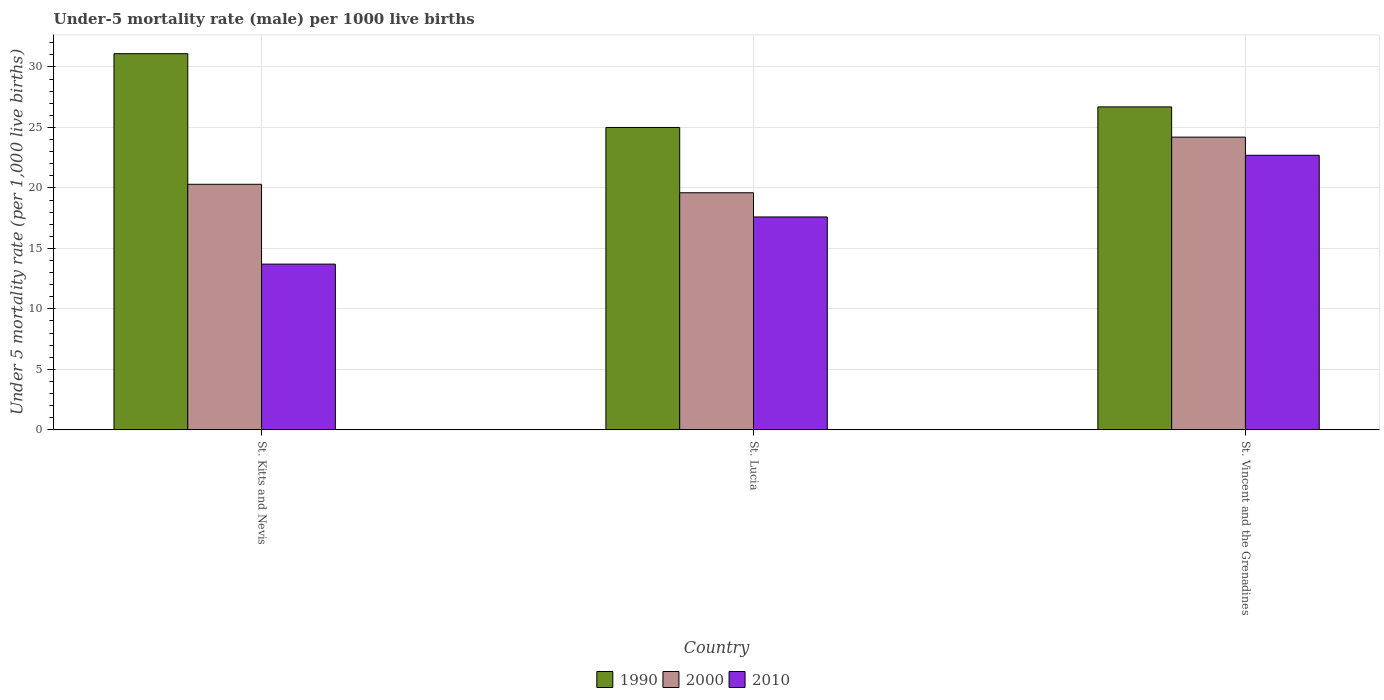Are the number of bars per tick equal to the number of legend labels?
Make the answer very short. Yes. What is the label of the 1st group of bars from the left?
Offer a terse response. St. Kitts and Nevis. Across all countries, what is the maximum under-five mortality rate in 2000?
Keep it short and to the point. 24.2. In which country was the under-five mortality rate in 2010 maximum?
Keep it short and to the point. St. Vincent and the Grenadines. In which country was the under-five mortality rate in 2000 minimum?
Ensure brevity in your answer.  St. Lucia. What is the total under-five mortality rate in 2010 in the graph?
Keep it short and to the point. 54. What is the difference between the under-five mortality rate in 2000 in St. Kitts and Nevis and that in St. Vincent and the Grenadines?
Keep it short and to the point. -3.9. What is the difference between the under-five mortality rate in 1990 in St. Vincent and the Grenadines and the under-five mortality rate in 2010 in St. Kitts and Nevis?
Offer a very short reply. 13. What is the average under-five mortality rate in 2000 per country?
Your answer should be compact. 21.37. What is the difference between the under-five mortality rate of/in 2000 and under-five mortality rate of/in 2010 in St. Kitts and Nevis?
Give a very brief answer. 6.6. What is the ratio of the under-five mortality rate in 2000 in St. Kitts and Nevis to that in St. Vincent and the Grenadines?
Ensure brevity in your answer.  0.84. What is the difference between the highest and the second highest under-five mortality rate in 1990?
Offer a terse response. -1.7. In how many countries, is the under-five mortality rate in 2010 greater than the average under-five mortality rate in 2010 taken over all countries?
Your answer should be compact. 1. What does the 2nd bar from the left in St. Kitts and Nevis represents?
Ensure brevity in your answer.  2000. What does the 3rd bar from the right in St. Kitts and Nevis represents?
Make the answer very short. 1990. Are all the bars in the graph horizontal?
Keep it short and to the point. No. How many countries are there in the graph?
Provide a succinct answer. 3. What is the difference between two consecutive major ticks on the Y-axis?
Give a very brief answer. 5. Are the values on the major ticks of Y-axis written in scientific E-notation?
Provide a short and direct response. No. Does the graph contain grids?
Your response must be concise. Yes. How many legend labels are there?
Give a very brief answer. 3. What is the title of the graph?
Your response must be concise. Under-5 mortality rate (male) per 1000 live births. Does "2007" appear as one of the legend labels in the graph?
Offer a very short reply. No. What is the label or title of the X-axis?
Keep it short and to the point. Country. What is the label or title of the Y-axis?
Provide a short and direct response. Under 5 mortality rate (per 1,0 live births). What is the Under 5 mortality rate (per 1,000 live births) of 1990 in St. Kitts and Nevis?
Keep it short and to the point. 31.1. What is the Under 5 mortality rate (per 1,000 live births) of 2000 in St. Kitts and Nevis?
Give a very brief answer. 20.3. What is the Under 5 mortality rate (per 1,000 live births) of 2010 in St. Kitts and Nevis?
Your answer should be very brief. 13.7. What is the Under 5 mortality rate (per 1,000 live births) of 2000 in St. Lucia?
Offer a very short reply. 19.6. What is the Under 5 mortality rate (per 1,000 live births) of 1990 in St. Vincent and the Grenadines?
Make the answer very short. 26.7. What is the Under 5 mortality rate (per 1,000 live births) of 2000 in St. Vincent and the Grenadines?
Your answer should be compact. 24.2. What is the Under 5 mortality rate (per 1,000 live births) in 2010 in St. Vincent and the Grenadines?
Your response must be concise. 22.7. Across all countries, what is the maximum Under 5 mortality rate (per 1,000 live births) of 1990?
Your answer should be very brief. 31.1. Across all countries, what is the maximum Under 5 mortality rate (per 1,000 live births) in 2000?
Provide a succinct answer. 24.2. Across all countries, what is the maximum Under 5 mortality rate (per 1,000 live births) of 2010?
Your answer should be compact. 22.7. Across all countries, what is the minimum Under 5 mortality rate (per 1,000 live births) in 2000?
Give a very brief answer. 19.6. What is the total Under 5 mortality rate (per 1,000 live births) of 1990 in the graph?
Offer a terse response. 82.8. What is the total Under 5 mortality rate (per 1,000 live births) of 2000 in the graph?
Offer a very short reply. 64.1. What is the total Under 5 mortality rate (per 1,000 live births) of 2010 in the graph?
Offer a terse response. 54. What is the difference between the Under 5 mortality rate (per 1,000 live births) of 1990 in St. Kitts and Nevis and that in St. Lucia?
Provide a succinct answer. 6.1. What is the difference between the Under 5 mortality rate (per 1,000 live births) in 1990 in St. Kitts and Nevis and that in St. Vincent and the Grenadines?
Provide a succinct answer. 4.4. What is the difference between the Under 5 mortality rate (per 1,000 live births) of 2000 in St. Kitts and Nevis and that in St. Vincent and the Grenadines?
Provide a succinct answer. -3.9. What is the difference between the Under 5 mortality rate (per 1,000 live births) of 2000 in St. Lucia and that in St. Vincent and the Grenadines?
Keep it short and to the point. -4.6. What is the difference between the Under 5 mortality rate (per 1,000 live births) of 1990 in St. Kitts and Nevis and the Under 5 mortality rate (per 1,000 live births) of 2010 in St. Lucia?
Ensure brevity in your answer.  13.5. What is the difference between the Under 5 mortality rate (per 1,000 live births) in 1990 in St. Kitts and Nevis and the Under 5 mortality rate (per 1,000 live births) in 2010 in St. Vincent and the Grenadines?
Offer a terse response. 8.4. What is the average Under 5 mortality rate (per 1,000 live births) in 1990 per country?
Make the answer very short. 27.6. What is the average Under 5 mortality rate (per 1,000 live births) of 2000 per country?
Keep it short and to the point. 21.37. What is the average Under 5 mortality rate (per 1,000 live births) of 2010 per country?
Provide a succinct answer. 18. What is the difference between the Under 5 mortality rate (per 1,000 live births) of 2000 and Under 5 mortality rate (per 1,000 live births) of 2010 in St. Kitts and Nevis?
Your answer should be compact. 6.6. What is the difference between the Under 5 mortality rate (per 1,000 live births) of 1990 and Under 5 mortality rate (per 1,000 live births) of 2000 in St. Lucia?
Ensure brevity in your answer.  5.4. What is the difference between the Under 5 mortality rate (per 1,000 live births) in 1990 and Under 5 mortality rate (per 1,000 live births) in 2010 in St. Lucia?
Offer a very short reply. 7.4. What is the difference between the Under 5 mortality rate (per 1,000 live births) in 1990 and Under 5 mortality rate (per 1,000 live births) in 2000 in St. Vincent and the Grenadines?
Your answer should be very brief. 2.5. What is the difference between the Under 5 mortality rate (per 1,000 live births) of 1990 and Under 5 mortality rate (per 1,000 live births) of 2010 in St. Vincent and the Grenadines?
Your answer should be very brief. 4. What is the difference between the Under 5 mortality rate (per 1,000 live births) in 2000 and Under 5 mortality rate (per 1,000 live births) in 2010 in St. Vincent and the Grenadines?
Provide a succinct answer. 1.5. What is the ratio of the Under 5 mortality rate (per 1,000 live births) of 1990 in St. Kitts and Nevis to that in St. Lucia?
Offer a very short reply. 1.24. What is the ratio of the Under 5 mortality rate (per 1,000 live births) of 2000 in St. Kitts and Nevis to that in St. Lucia?
Provide a succinct answer. 1.04. What is the ratio of the Under 5 mortality rate (per 1,000 live births) in 2010 in St. Kitts and Nevis to that in St. Lucia?
Your response must be concise. 0.78. What is the ratio of the Under 5 mortality rate (per 1,000 live births) of 1990 in St. Kitts and Nevis to that in St. Vincent and the Grenadines?
Offer a very short reply. 1.16. What is the ratio of the Under 5 mortality rate (per 1,000 live births) in 2000 in St. Kitts and Nevis to that in St. Vincent and the Grenadines?
Your answer should be compact. 0.84. What is the ratio of the Under 5 mortality rate (per 1,000 live births) in 2010 in St. Kitts and Nevis to that in St. Vincent and the Grenadines?
Your answer should be very brief. 0.6. What is the ratio of the Under 5 mortality rate (per 1,000 live births) in 1990 in St. Lucia to that in St. Vincent and the Grenadines?
Offer a terse response. 0.94. What is the ratio of the Under 5 mortality rate (per 1,000 live births) of 2000 in St. Lucia to that in St. Vincent and the Grenadines?
Your response must be concise. 0.81. What is the ratio of the Under 5 mortality rate (per 1,000 live births) of 2010 in St. Lucia to that in St. Vincent and the Grenadines?
Ensure brevity in your answer.  0.78. What is the difference between the highest and the second highest Under 5 mortality rate (per 1,000 live births) in 1990?
Your answer should be compact. 4.4. What is the difference between the highest and the second highest Under 5 mortality rate (per 1,000 live births) of 2000?
Make the answer very short. 3.9. What is the difference between the highest and the second highest Under 5 mortality rate (per 1,000 live births) of 2010?
Ensure brevity in your answer.  5.1. What is the difference between the highest and the lowest Under 5 mortality rate (per 1,000 live births) of 1990?
Your answer should be compact. 6.1. What is the difference between the highest and the lowest Under 5 mortality rate (per 1,000 live births) in 2000?
Your answer should be compact. 4.6. What is the difference between the highest and the lowest Under 5 mortality rate (per 1,000 live births) of 2010?
Keep it short and to the point. 9. 